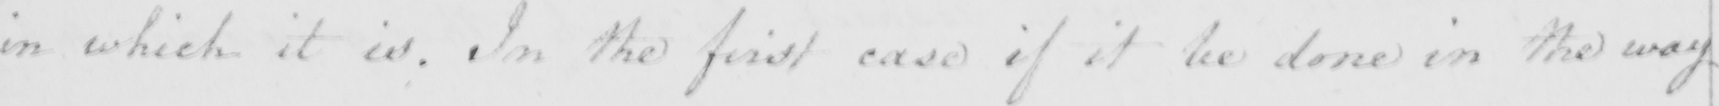Transcribe the text shown in this historical manuscript line. in which it is . In the first case if it be done in the way 